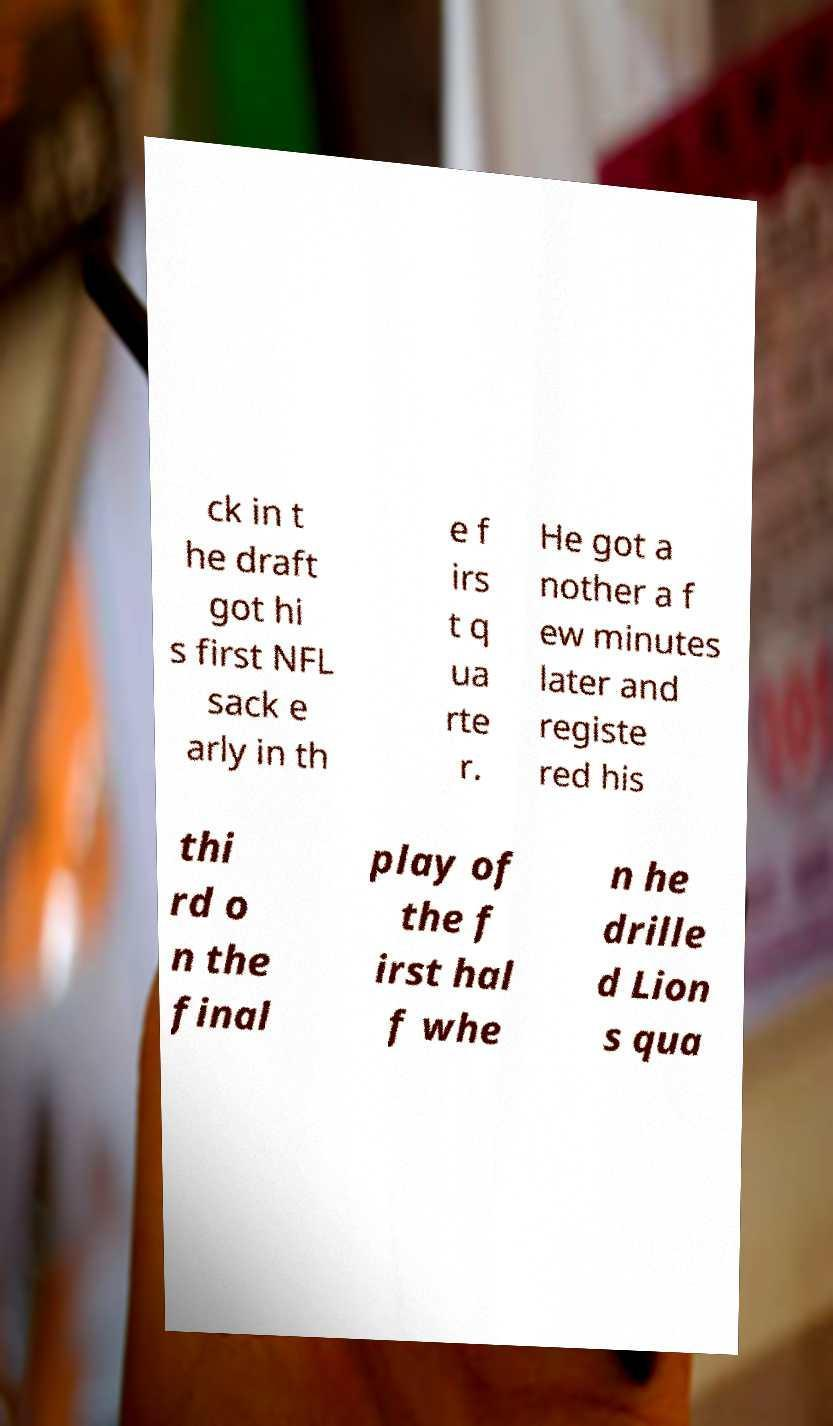Could you extract and type out the text from this image? ck in t he draft got hi s first NFL sack e arly in th e f irs t q ua rte r. He got a nother a f ew minutes later and registe red his thi rd o n the final play of the f irst hal f whe n he drille d Lion s qua 